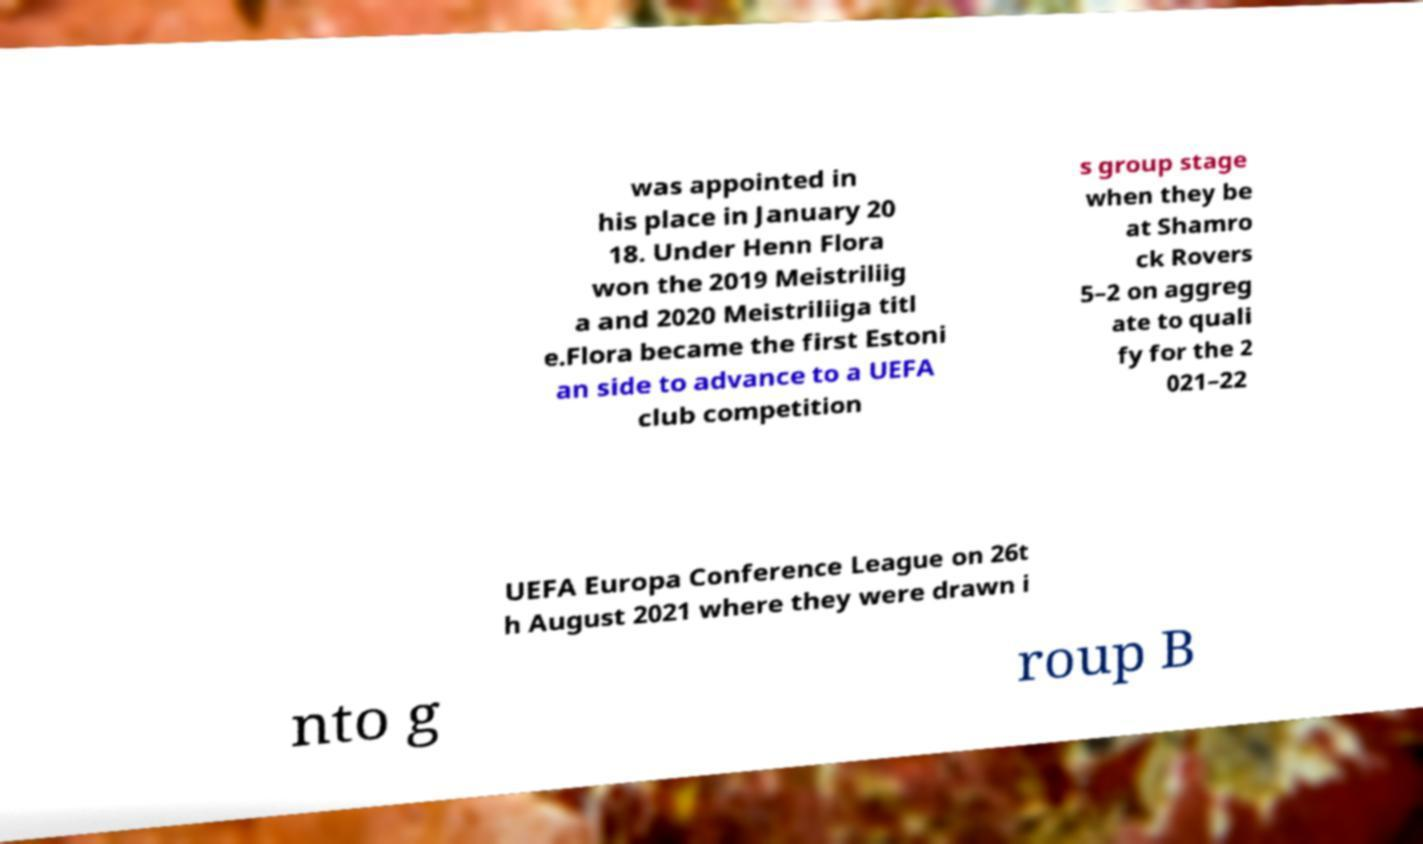Can you read and provide the text displayed in the image?This photo seems to have some interesting text. Can you extract and type it out for me? was appointed in his place in January 20 18. Under Henn Flora won the 2019 Meistriliig a and 2020 Meistriliiga titl e.Flora became the first Estoni an side to advance to a UEFA club competition s group stage when they be at Shamro ck Rovers 5–2 on aggreg ate to quali fy for the 2 021–22 UEFA Europa Conference League on 26t h August 2021 where they were drawn i nto g roup B 